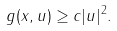<formula> <loc_0><loc_0><loc_500><loc_500>g ( x , u ) \geq c | u | ^ { 2 } .</formula> 